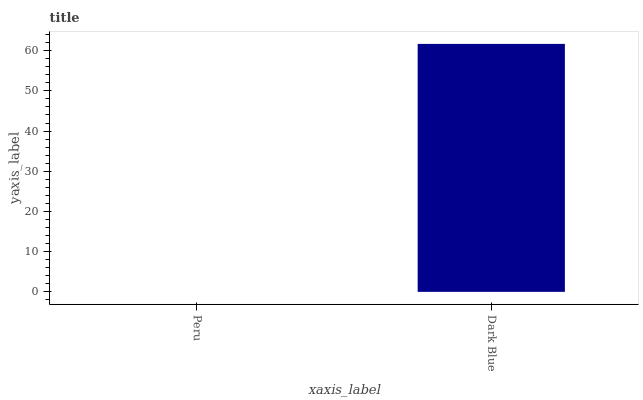Is Dark Blue the minimum?
Answer yes or no. No. Is Dark Blue greater than Peru?
Answer yes or no. Yes. Is Peru less than Dark Blue?
Answer yes or no. Yes. Is Peru greater than Dark Blue?
Answer yes or no. No. Is Dark Blue less than Peru?
Answer yes or no. No. Is Dark Blue the high median?
Answer yes or no. Yes. Is Peru the low median?
Answer yes or no. Yes. Is Peru the high median?
Answer yes or no. No. Is Dark Blue the low median?
Answer yes or no. No. 